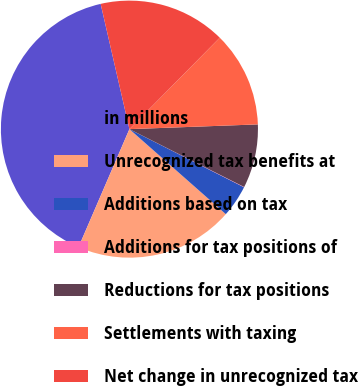<chart> <loc_0><loc_0><loc_500><loc_500><pie_chart><fcel>in millions<fcel>Unrecognized tax benefits at<fcel>Additions based on tax<fcel>Additions for tax positions of<fcel>Reductions for tax positions<fcel>Settlements with taxing<fcel>Net change in unrecognized tax<nl><fcel>39.93%<fcel>19.98%<fcel>4.03%<fcel>0.04%<fcel>8.02%<fcel>12.01%<fcel>16.0%<nl></chart> 